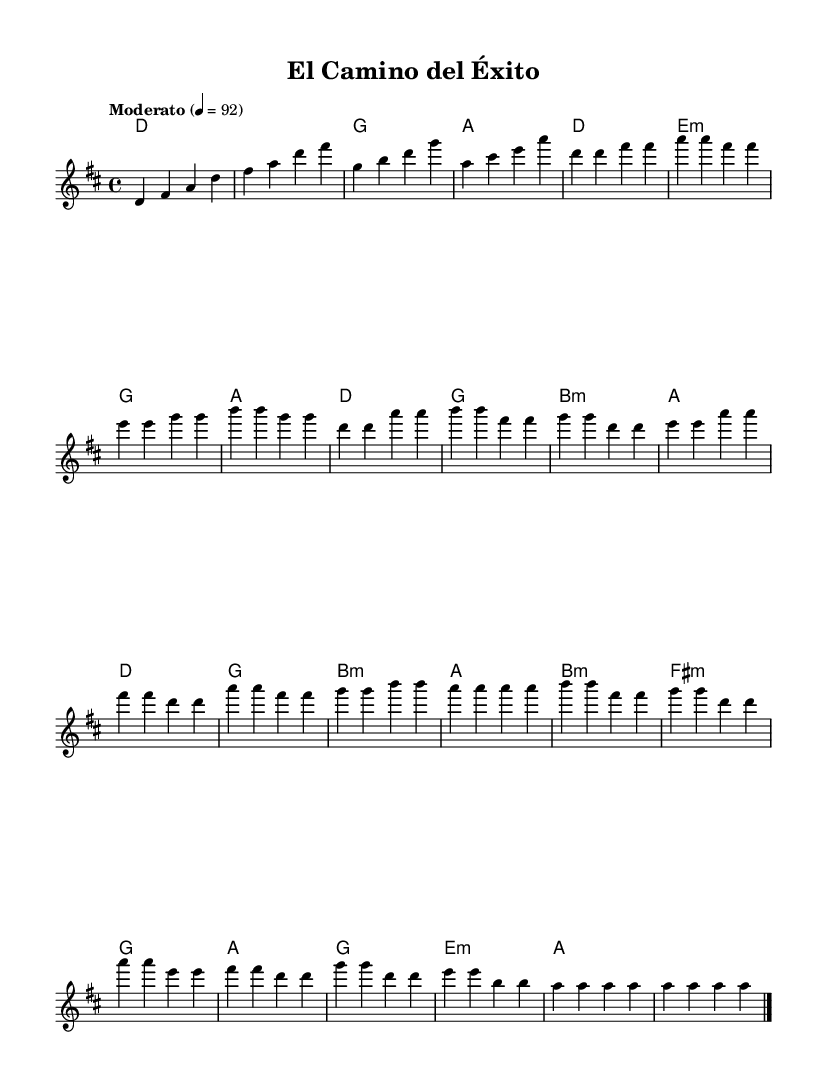What is the key signature of this music? The key signature is D major, which includes two sharps: F# and C#.
Answer: D major What is the time signature of this music? The time signature is 4/4, commonly known as "four-four" time, indicating four beats per measure.
Answer: 4/4 What is the tempo marking of this piece? The tempo marking is "Moderato," which indicates a moderate pace, generally between 98 and 109 beats per minute.
Answer: Moderato How many measures are in the chorus section? The chorus section consists of four measures, each containing two phrases of music, making a total of eight measures.
Answer: 4 What harmonies are used in the bridge? The harmonies used in the bridge are B minor, F# minor, G, and A, providing a mix of minor and major chords for contrast.
Answer: B minor, F# minor, G, A What is the main theme of the lyrics likely based on the title "El Camino del Éxito"? The title translates to "The Path to Success," suggesting themes of personal growth and self-discovery throughout the lyrics.
Answer: Personal growth Which chords are used in the intro? The chords used in the intro are D, D, G, and A, starting the piece with a strong tonic chord followed by the dominant and subdominant.
Answer: D, D, G, A 